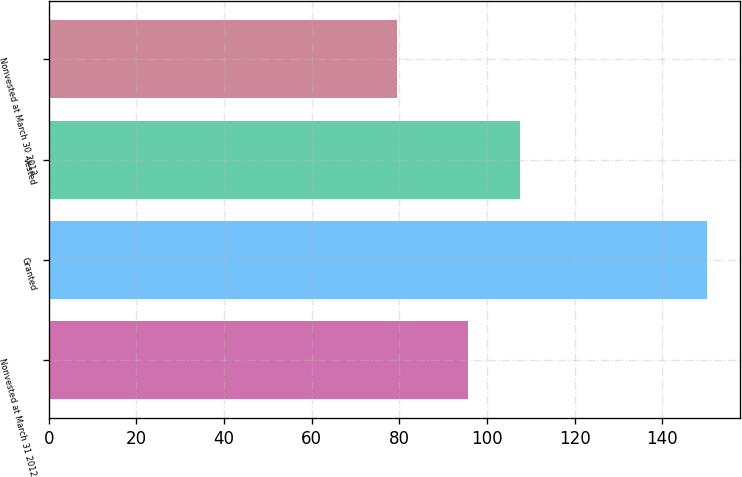Convert chart to OTSL. <chart><loc_0><loc_0><loc_500><loc_500><bar_chart><fcel>Nonvested at March 31 2012<fcel>Granted<fcel>Vested<fcel>Nonvested at March 30 2013<nl><fcel>95.57<fcel>150.17<fcel>107.46<fcel>79.52<nl></chart> 